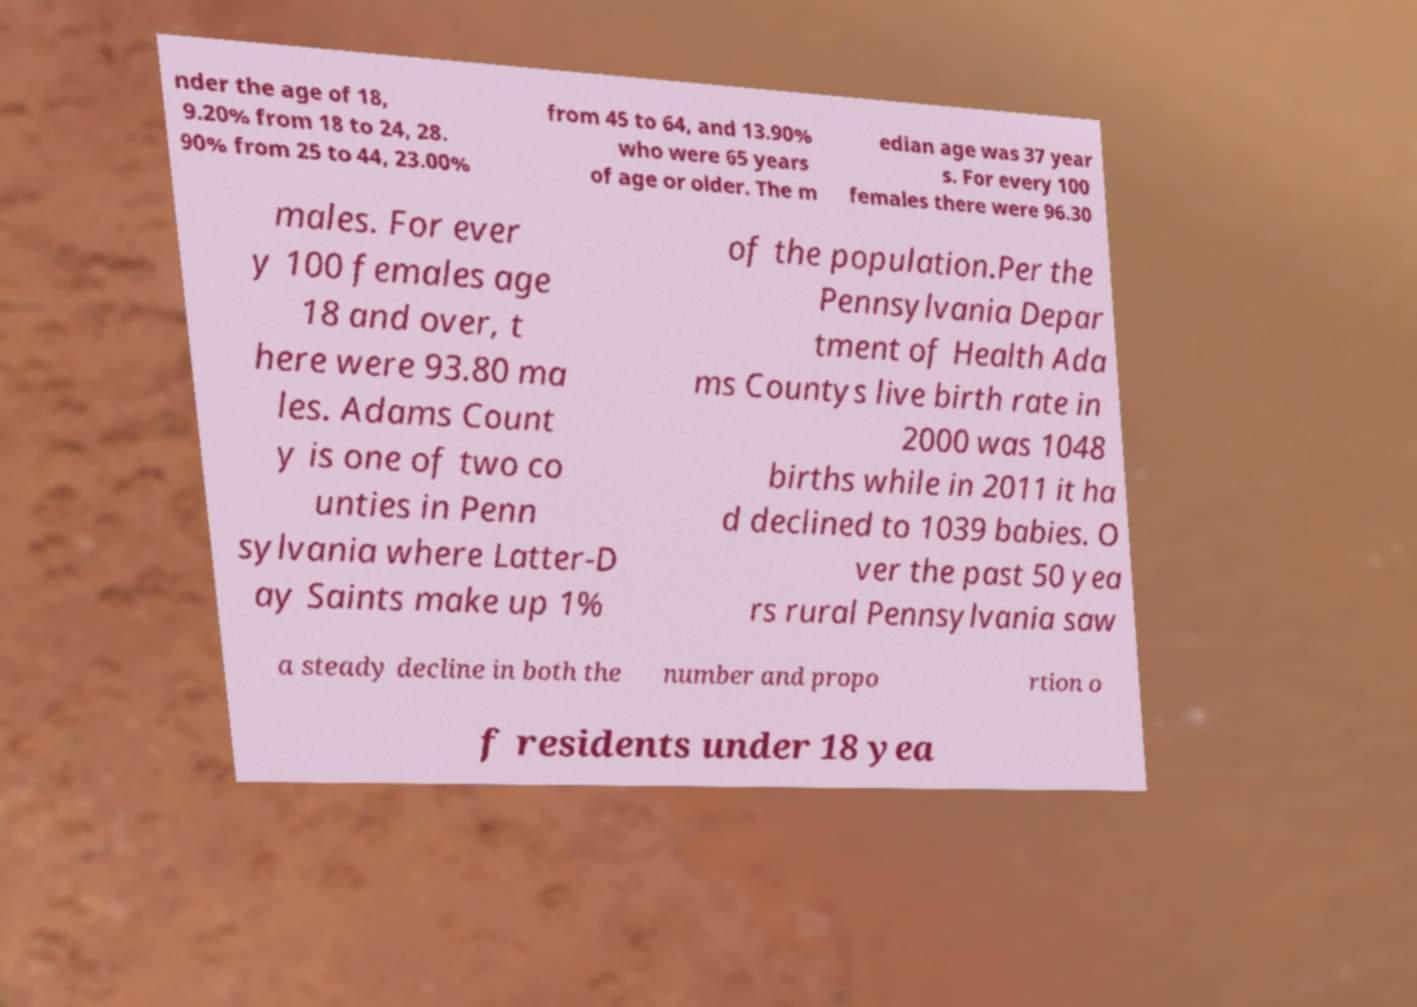Could you extract and type out the text from this image? nder the age of 18, 9.20% from 18 to 24, 28. 90% from 25 to 44, 23.00% from 45 to 64, and 13.90% who were 65 years of age or older. The m edian age was 37 year s. For every 100 females there were 96.30 males. For ever y 100 females age 18 and over, t here were 93.80 ma les. Adams Count y is one of two co unties in Penn sylvania where Latter-D ay Saints make up 1% of the population.Per the Pennsylvania Depar tment of Health Ada ms Countys live birth rate in 2000 was 1048 births while in 2011 it ha d declined to 1039 babies. O ver the past 50 yea rs rural Pennsylvania saw a steady decline in both the number and propo rtion o f residents under 18 yea 